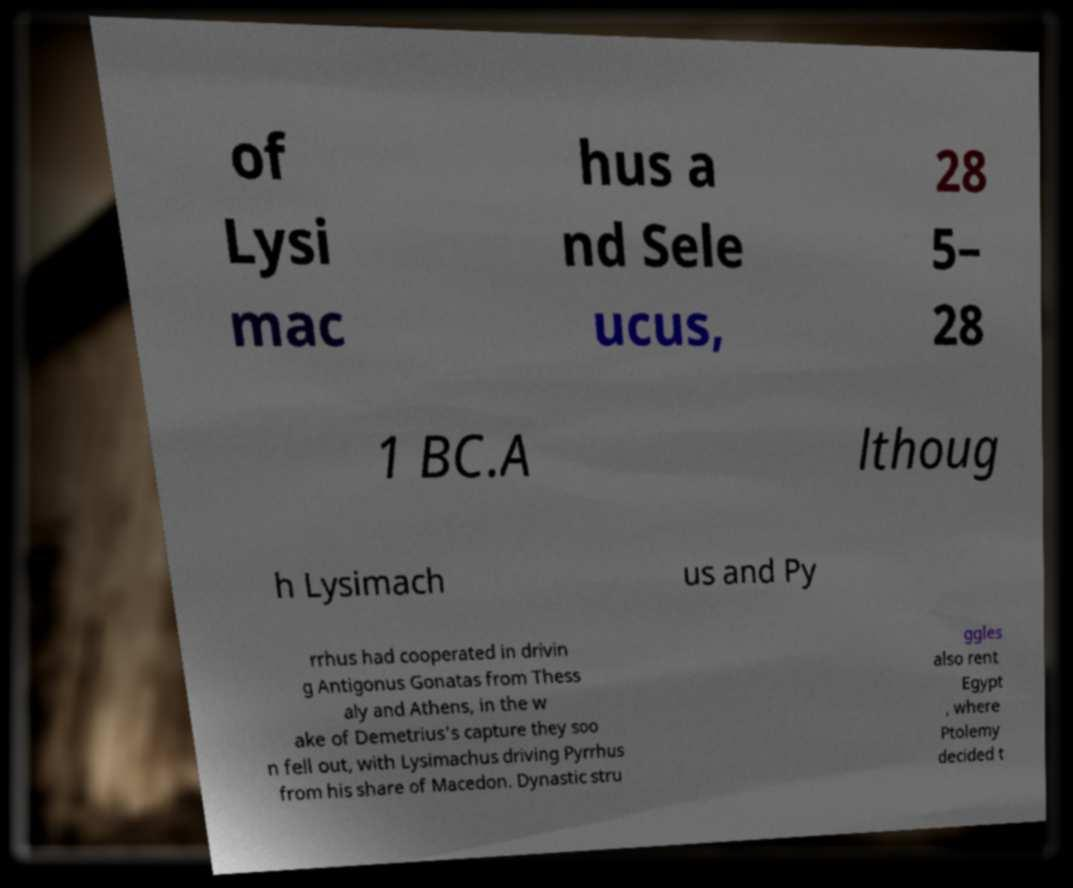Could you assist in decoding the text presented in this image and type it out clearly? of Lysi mac hus a nd Sele ucus, 28 5– 28 1 BC.A lthoug h Lysimach us and Py rrhus had cooperated in drivin g Antigonus Gonatas from Thess aly and Athens, in the w ake of Demetrius's capture they soo n fell out, with Lysimachus driving Pyrrhus from his share of Macedon. Dynastic stru ggles also rent Egypt , where Ptolemy decided t 